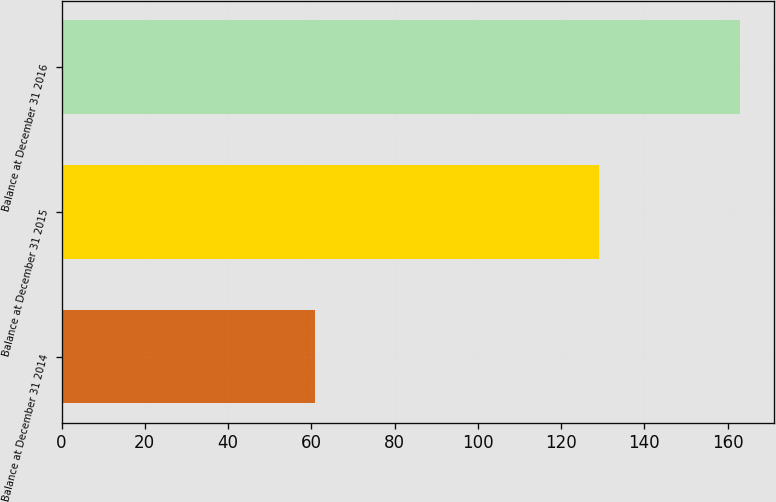Convert chart to OTSL. <chart><loc_0><loc_0><loc_500><loc_500><bar_chart><fcel>Balance at December 31 2014<fcel>Balance at December 31 2015<fcel>Balance at December 31 2016<nl><fcel>61<fcel>129<fcel>163<nl></chart> 